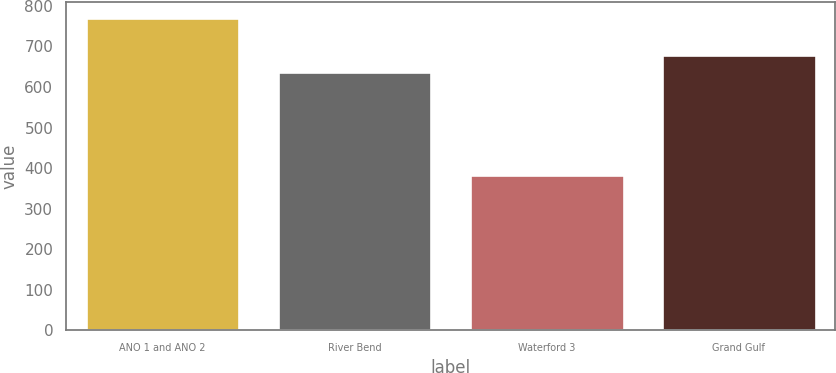Convert chart to OTSL. <chart><loc_0><loc_0><loc_500><loc_500><bar_chart><fcel>ANO 1 and ANO 2<fcel>River Bend<fcel>Waterford 3<fcel>Grand Gulf<nl><fcel>769.9<fcel>637.7<fcel>383.6<fcel>679.8<nl></chart> 